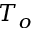Convert formula to latex. <formula><loc_0><loc_0><loc_500><loc_500>T _ { o }</formula> 